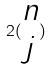<formula> <loc_0><loc_0><loc_500><loc_500>2 ( \begin{matrix} n \\ j \end{matrix} )</formula> 